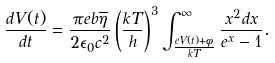<formula> <loc_0><loc_0><loc_500><loc_500>\frac { d V ( t ) } { d t } = \frac { \pi e b \overline { \eta } } { 2 \epsilon _ { 0 } c ^ { 2 } } \left ( \frac { k T } { h } \right ) ^ { 3 } \int _ { \frac { e V ( t ) + \phi } { k T } } ^ { \infty } \frac { x ^ { 2 } d x } { e ^ { x } - 1 } .</formula> 